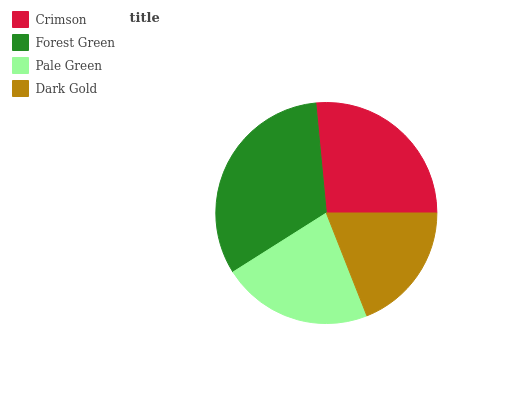Is Dark Gold the minimum?
Answer yes or no. Yes. Is Forest Green the maximum?
Answer yes or no. Yes. Is Pale Green the minimum?
Answer yes or no. No. Is Pale Green the maximum?
Answer yes or no. No. Is Forest Green greater than Pale Green?
Answer yes or no. Yes. Is Pale Green less than Forest Green?
Answer yes or no. Yes. Is Pale Green greater than Forest Green?
Answer yes or no. No. Is Forest Green less than Pale Green?
Answer yes or no. No. Is Crimson the high median?
Answer yes or no. Yes. Is Pale Green the low median?
Answer yes or no. Yes. Is Pale Green the high median?
Answer yes or no. No. Is Forest Green the low median?
Answer yes or no. No. 